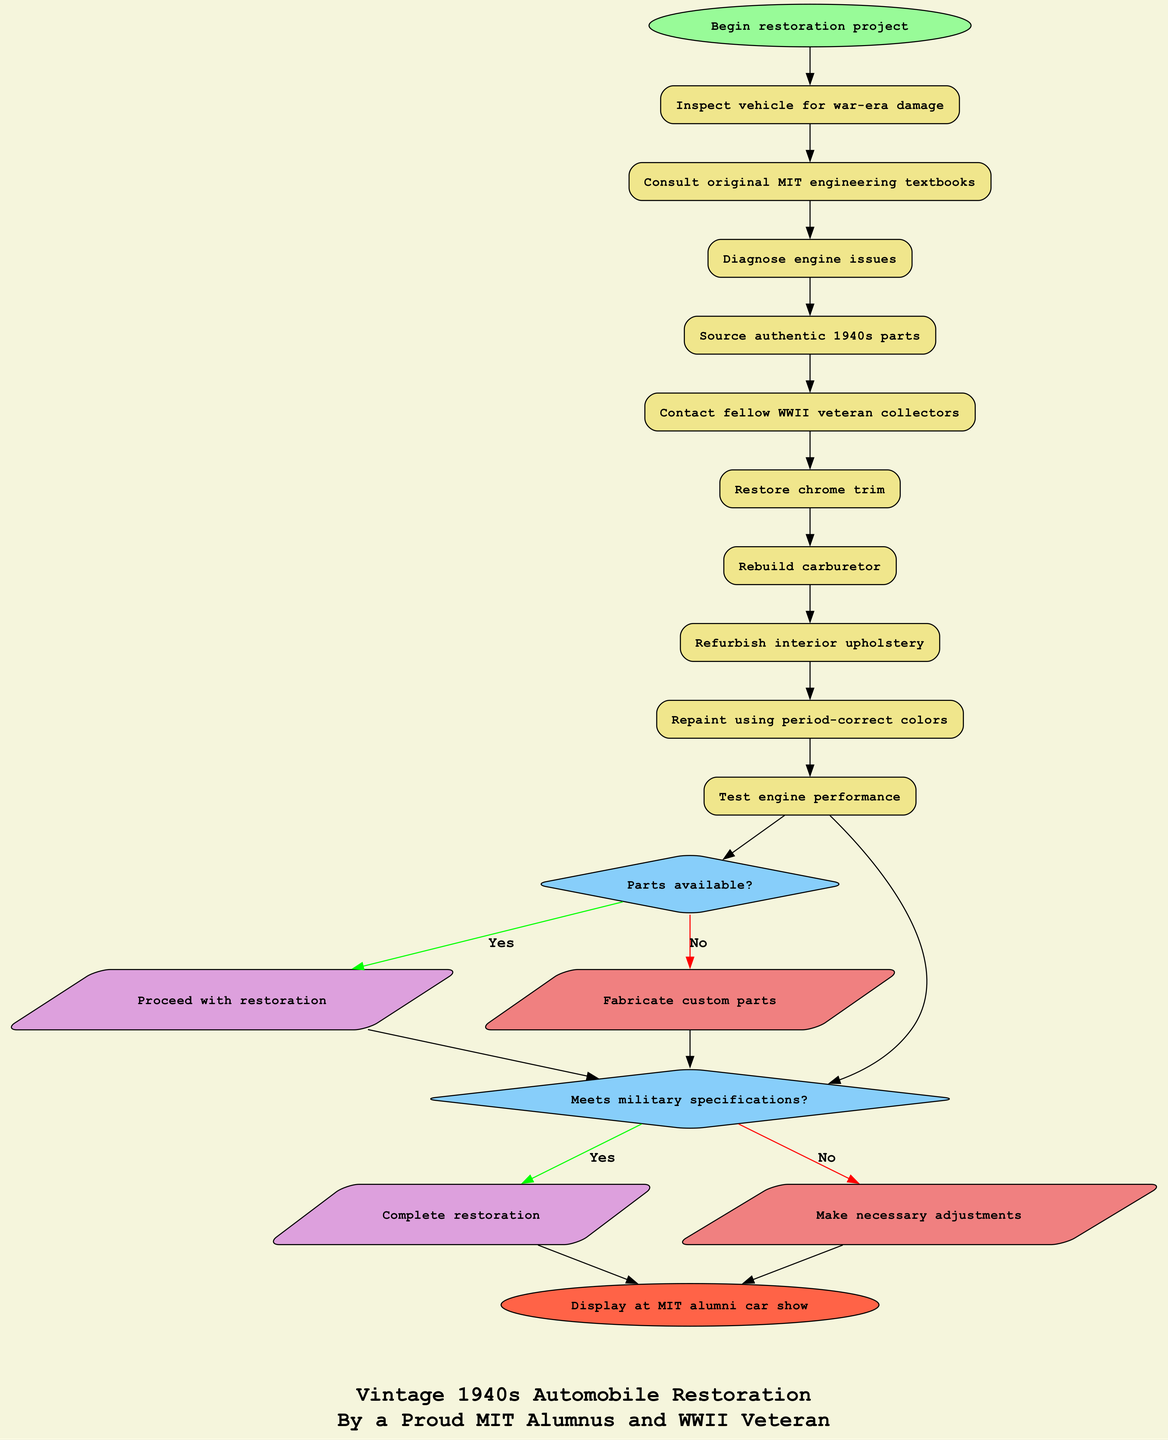What is the first activity in the restoration project? The diagram specifies the first activity by linking it directly to the start node. Referring to the "activities" section of the data, the first activity listed is "Inspect vehicle for war-era damage."
Answer: Inspect vehicle for war-era damage How many activities are included in the diagram? The diagram can be analyzed by counting the activities under the "activities" section. There are ten listed activities.
Answer: 10 What is the last decision point in the diagram? The diagram outlines decision points after the activities. The last decision listed in the "decisions" section is "Meets military specifications?" It indicates the final evaluation before concluding the restoration.
Answer: Meets military specifications? What happens if the answer to "Parts available?" is 'No'? The diagram indicates that if the decision "Parts available?" yields 'No', the flow will lead to "Fabricate custom parts." This shows the alternate route taken.
Answer: Fabricate custom parts Which activity directly precedes "Test engine performance"? By following the flow of activities linked in the diagram, we can see "Repaint using period-correct colors" is the activity that comes just before "Test engine performance."
Answer: Repaint using period-correct colors What is the endpoint of the process in the diagram? The endpoint is indicated clearly at the end of the flow, leading to "Display at MIT alumni car show". This is where the entire process culminates.
Answer: Display at MIT alumni car show What are the two outcomes after the last decision point? The last decision point "Meets military specifications?" has two possible outcomes: "Complete restoration" for a 'Yes' answer, and "Make necessary adjustments" for a 'No' answer. Both outcomes arise from the same decision point.
Answer: Complete restoration, Make necessary adjustments If "Contact fellow WWII veteran collectors" is completed, which activity comes next? In tracing the activity flow, we find that "Contact fellow WWII veteran collectors" is followed by "Restore chrome trim," linking directly to the next activity.
Answer: Restore chrome trim How many decision points are present in the diagram? The diagram illustrates two distinct decision points listed under the "decisions" section: "Parts available?" and "Meets military specifications?". Therefore, we have a total of two decision points.
Answer: 2 